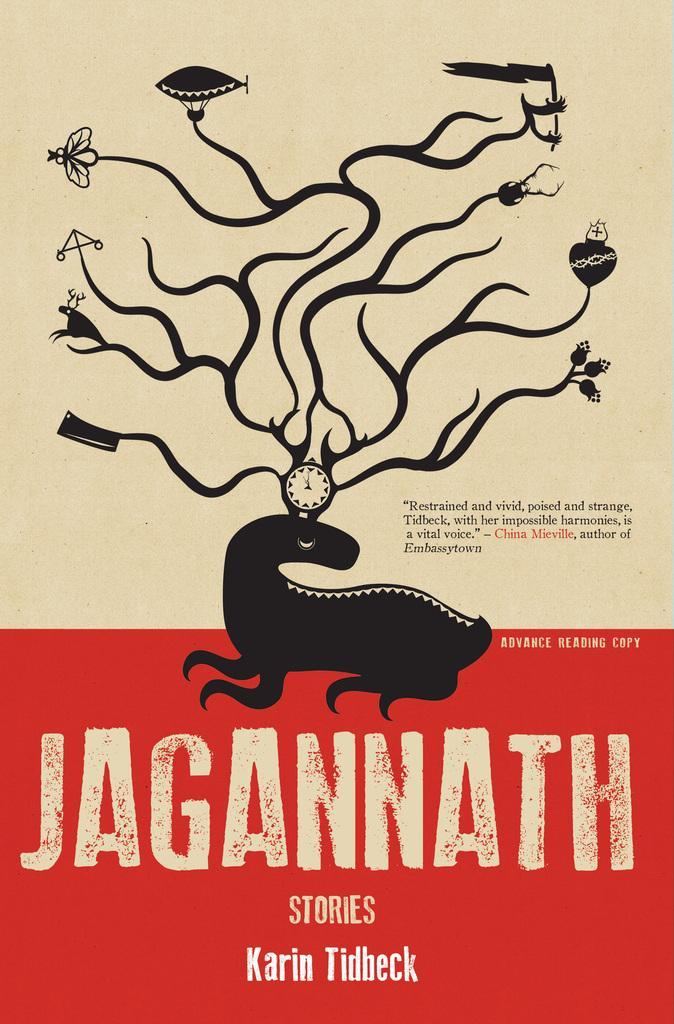Please provide a concise description of this image. In the image in the center we can see one poster. On the poster,it is written as "Jagannath". 